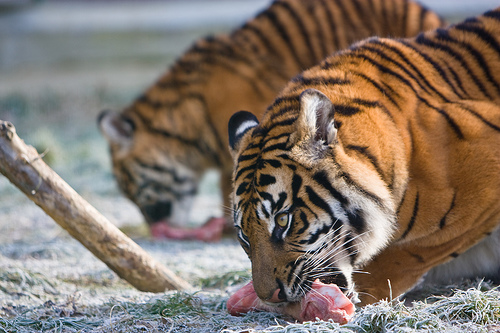<image>
Is there a tiger on the meat? Yes. Looking at the image, I can see the tiger is positioned on top of the meat, with the meat providing support. 